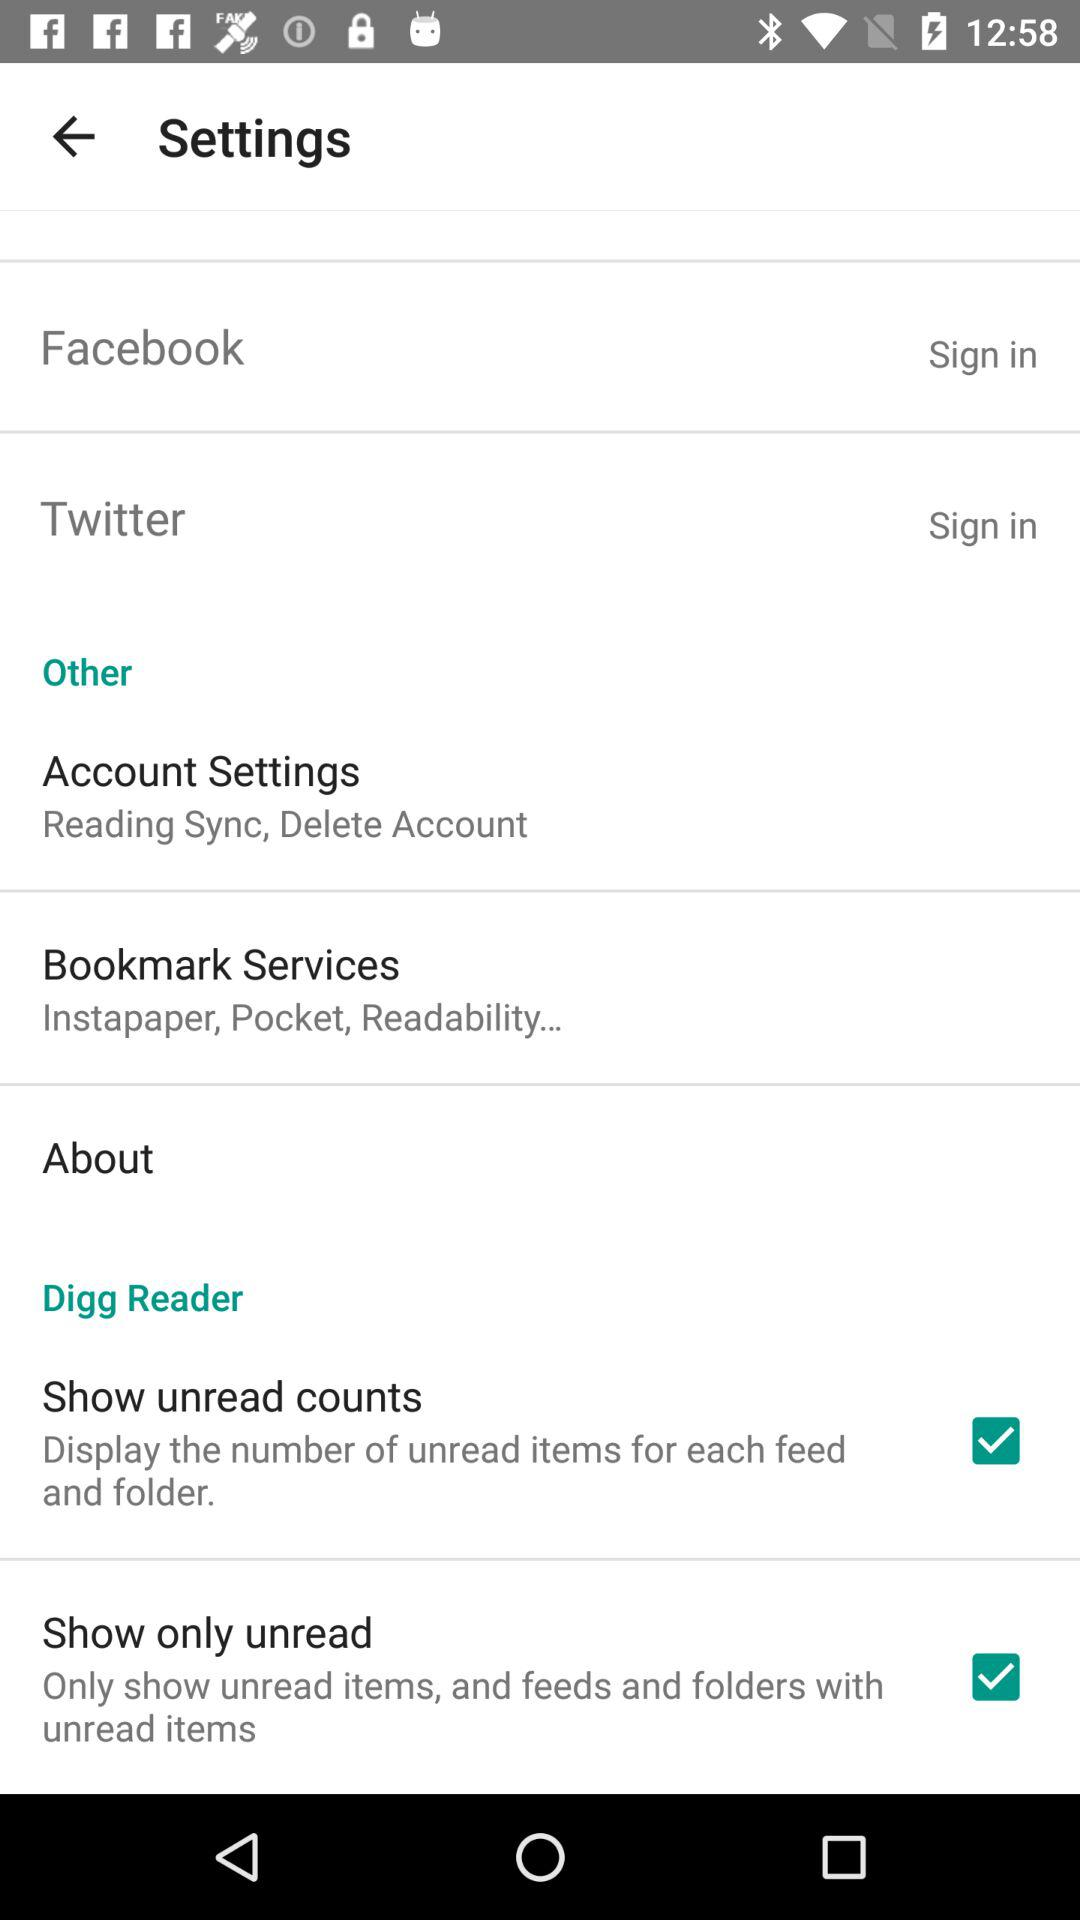What is the status of the "Show only unread"? The status of the "Show only unread" is "on". 